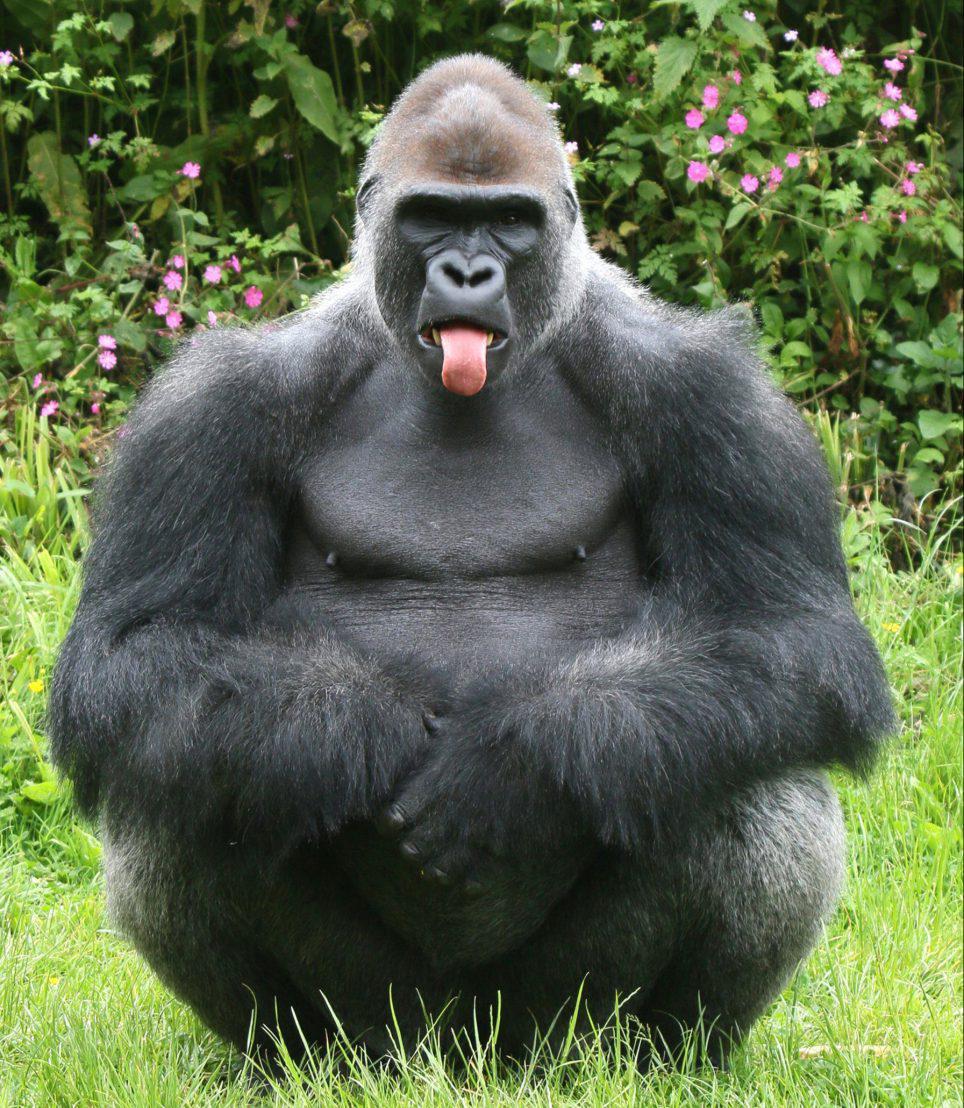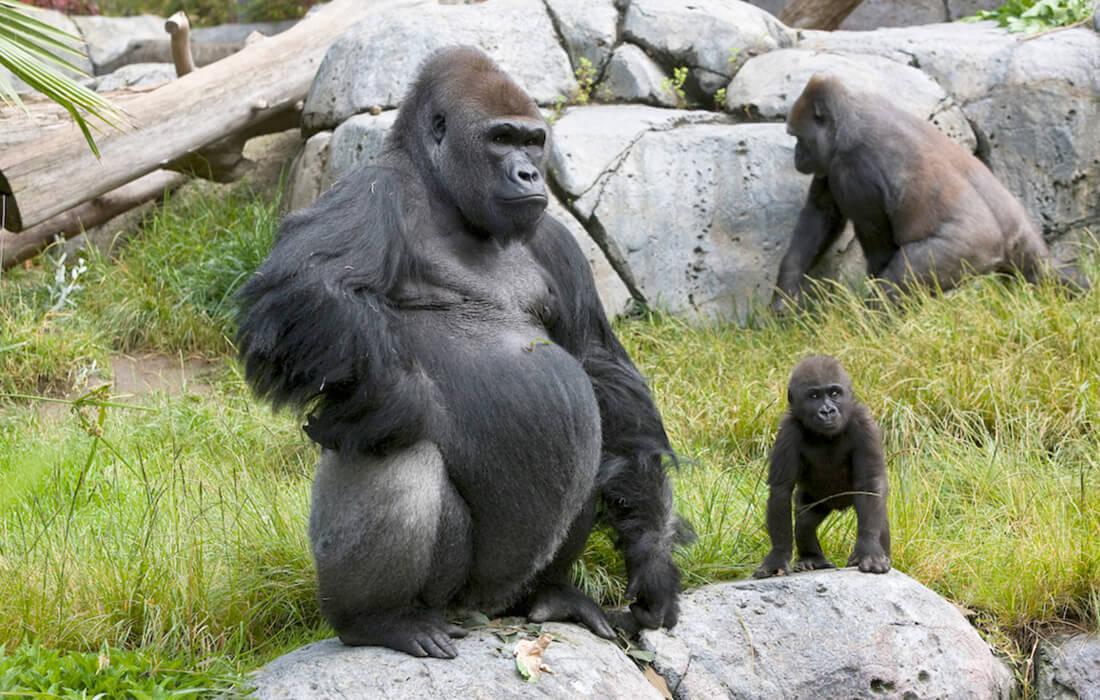The first image is the image on the left, the second image is the image on the right. Considering the images on both sides, is "A baby gorilla is with at least one adult in one image." valid? Answer yes or no. Yes. 